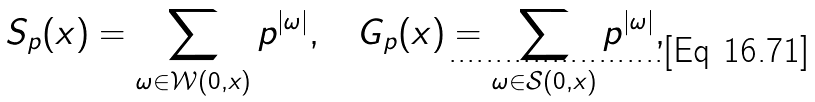<formula> <loc_0><loc_0><loc_500><loc_500>S _ { p } ( x ) = \sum _ { \omega \in \mathcal { W } ( 0 , x ) } p ^ { | \omega | } , \quad G _ { p } ( x ) = \sum _ { \omega \in \mathcal { S } ( 0 , x ) } p ^ { | \omega | } ,</formula> 